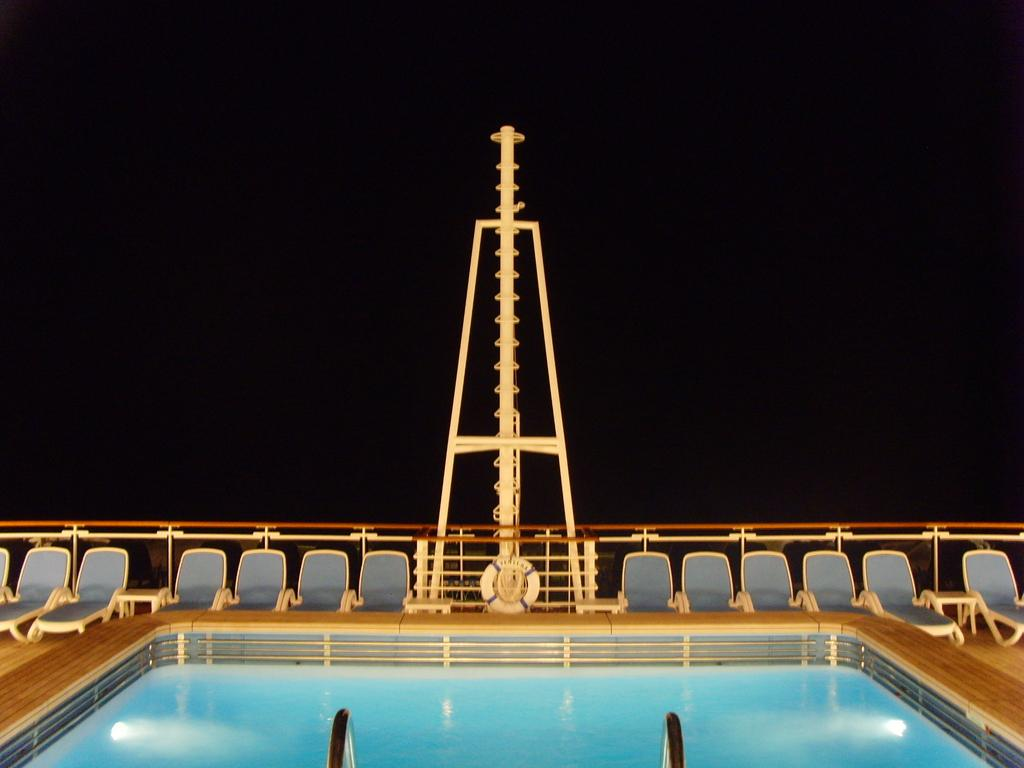What is the main feature of the image? There is a swimming pool in the image. Can you describe any specific elements within the swimming pool? There is a pole in the center of the swimming pool. What type of furniture is present in the image? Chaise loungers are present in the image. Are there any barriers or safety features visible in the image? Yes, there is a railing in the image. What type of cabbage is being used as a spoon in the image? There is no cabbage or spoon present in the image. What sign can be seen near the swimming pool in the image? There is no sign visible in the image. 